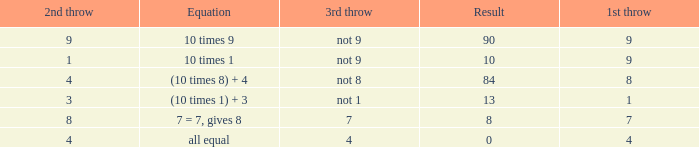What is the result when the 3rd throw is not 8? 84.0. 